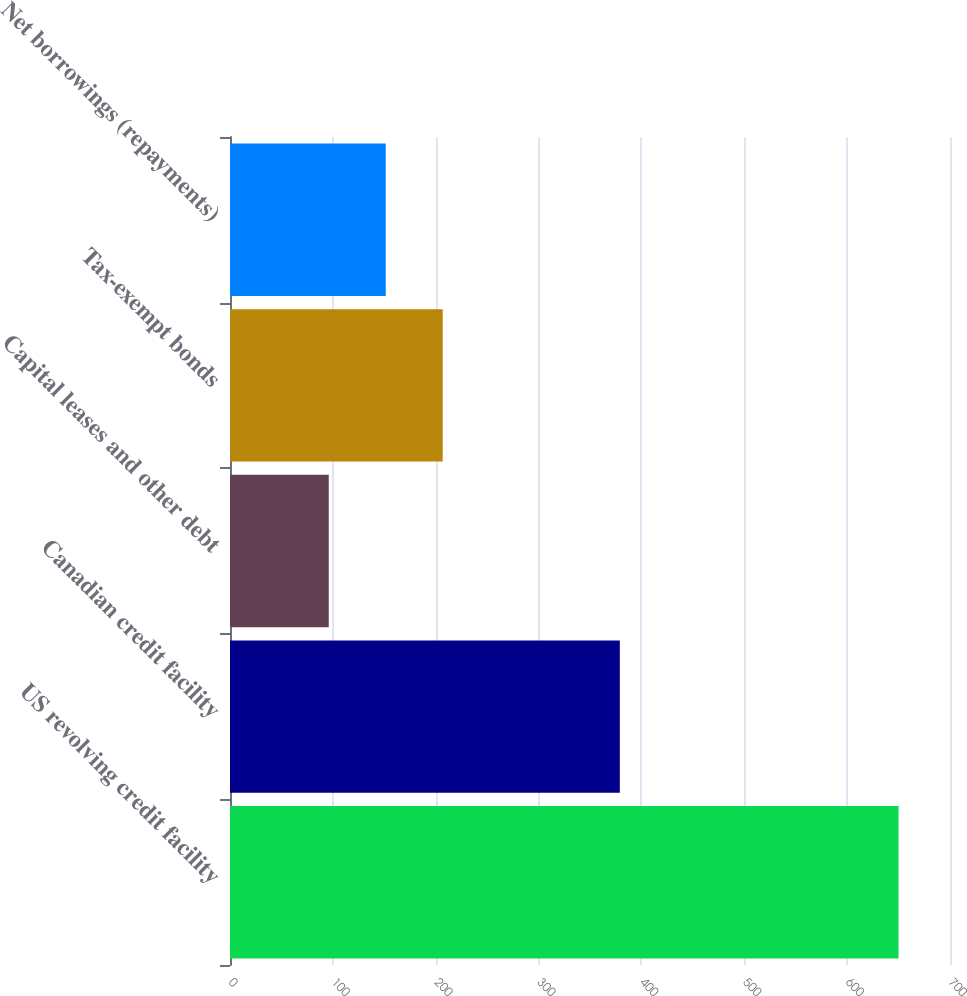Convert chart to OTSL. <chart><loc_0><loc_0><loc_500><loc_500><bar_chart><fcel>US revolving credit facility<fcel>Canadian credit facility<fcel>Capital leases and other debt<fcel>Tax-exempt bonds<fcel>Net borrowings (repayments)<nl><fcel>650<fcel>379<fcel>96<fcel>206.8<fcel>151.4<nl></chart> 